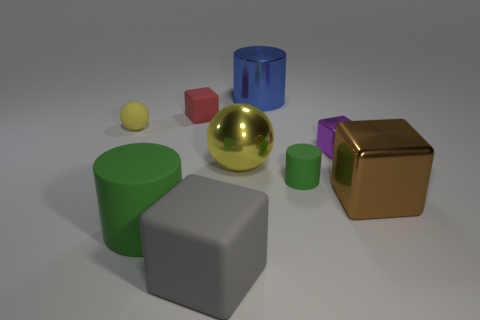What is the shape of the matte thing that is the same color as the small cylinder?
Your response must be concise. Cylinder. What number of things are either tiny cyan shiny things or big blocks that are in front of the big green cylinder?
Provide a succinct answer. 1. Do the cylinder that is left of the large gray cube and the tiny cylinder have the same color?
Your answer should be very brief. Yes. Are there more tiny blocks that are right of the yellow shiny thing than large gray cubes on the left side of the large gray cube?
Give a very brief answer. Yes. Is there any other thing of the same color as the matte ball?
Your answer should be compact. Yes. What number of things are matte things or yellow shiny spheres?
Provide a succinct answer. 6. Does the rubber thing on the right side of the yellow shiny object have the same size as the brown metal thing?
Give a very brief answer. No. How many other things are there of the same size as the metallic cylinder?
Your response must be concise. 4. Are any cyan rubber cylinders visible?
Offer a very short reply. No. There is a green object left of the green object behind the brown thing; how big is it?
Your answer should be very brief. Large. 